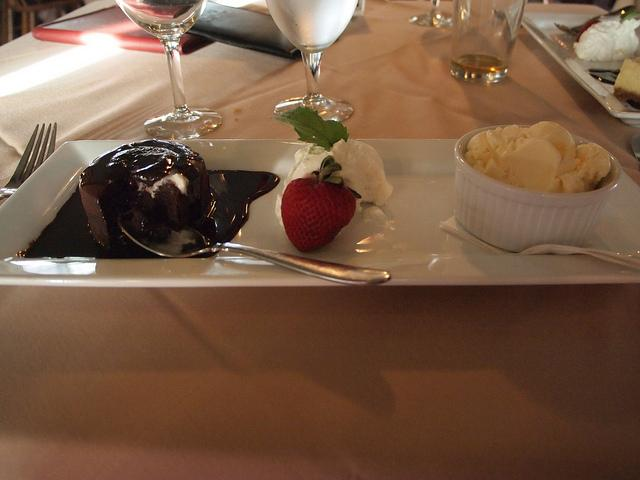What color is the chocolate on top of the white plate?

Choices:
A) brown
B) white
C) yellow
D) black black 